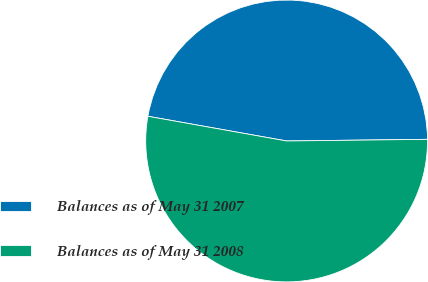<chart> <loc_0><loc_0><loc_500><loc_500><pie_chart><fcel>Balances as of May 31 2007<fcel>Balances as of May 31 2008<nl><fcel>47.01%<fcel>52.99%<nl></chart> 